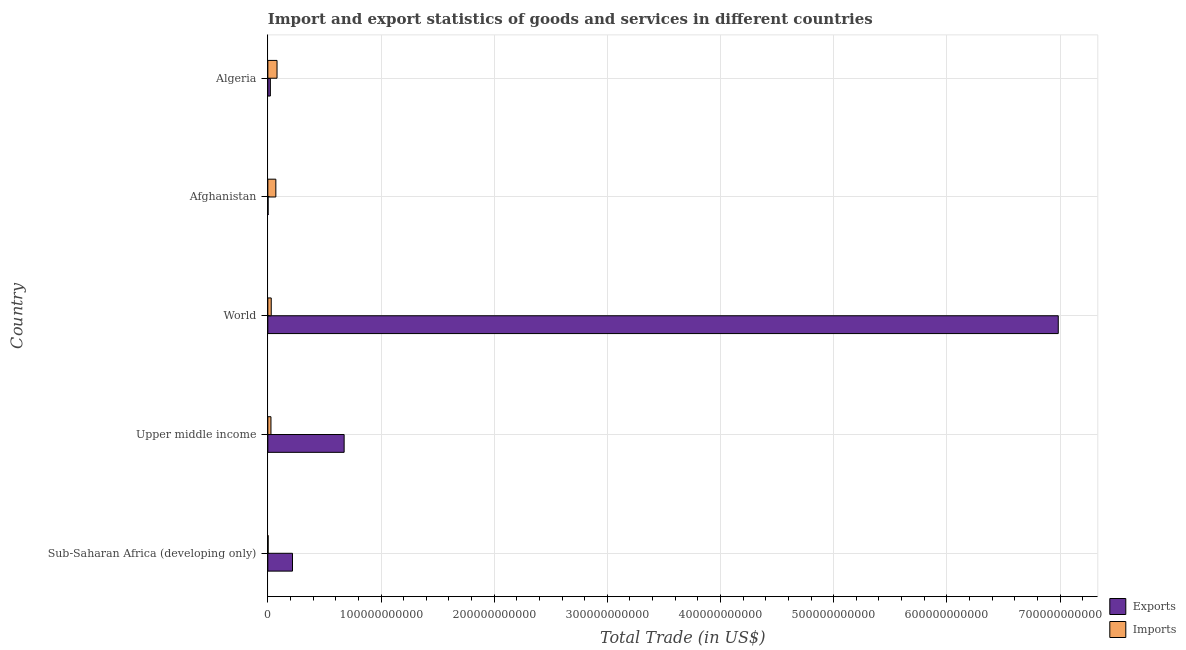Are the number of bars per tick equal to the number of legend labels?
Ensure brevity in your answer.  Yes. Are the number of bars on each tick of the Y-axis equal?
Provide a short and direct response. Yes. How many bars are there on the 2nd tick from the bottom?
Your response must be concise. 2. What is the label of the 3rd group of bars from the top?
Ensure brevity in your answer.  World. What is the imports of goods and services in Algeria?
Your response must be concise. 8.12e+09. Across all countries, what is the maximum imports of goods and services?
Your answer should be very brief. 8.12e+09. Across all countries, what is the minimum imports of goods and services?
Your answer should be very brief. 2.56e+08. In which country was the imports of goods and services minimum?
Ensure brevity in your answer.  Sub-Saharan Africa (developing only). What is the total imports of goods and services in the graph?
Provide a succinct answer. 2.12e+1. What is the difference between the imports of goods and services in Sub-Saharan Africa (developing only) and that in Upper middle income?
Make the answer very short. -2.50e+09. What is the difference between the imports of goods and services in Algeria and the export of goods and services in Afghanistan?
Offer a very short reply. 7.90e+09. What is the average export of goods and services per country?
Make the answer very short. 1.58e+11. What is the difference between the imports of goods and services and export of goods and services in Upper middle income?
Provide a succinct answer. -6.47e+1. In how many countries, is the imports of goods and services greater than 620000000000 US$?
Offer a very short reply. 0. What is the ratio of the export of goods and services in Algeria to that in Sub-Saharan Africa (developing only)?
Your response must be concise. 0.1. Is the difference between the export of goods and services in Afghanistan and Upper middle income greater than the difference between the imports of goods and services in Afghanistan and Upper middle income?
Provide a short and direct response. No. What is the difference between the highest and the second highest imports of goods and services?
Keep it short and to the point. 1.06e+09. What is the difference between the highest and the lowest imports of goods and services?
Offer a very short reply. 7.87e+09. Is the sum of the export of goods and services in Upper middle income and World greater than the maximum imports of goods and services across all countries?
Make the answer very short. Yes. What does the 1st bar from the top in World represents?
Ensure brevity in your answer.  Imports. What does the 1st bar from the bottom in Sub-Saharan Africa (developing only) represents?
Give a very brief answer. Exports. How many bars are there?
Make the answer very short. 10. Are all the bars in the graph horizontal?
Your answer should be compact. Yes. What is the difference between two consecutive major ticks on the X-axis?
Keep it short and to the point. 1.00e+11. Does the graph contain any zero values?
Your answer should be very brief. No. Does the graph contain grids?
Your answer should be compact. Yes. Where does the legend appear in the graph?
Your answer should be very brief. Bottom right. What is the title of the graph?
Your answer should be very brief. Import and export statistics of goods and services in different countries. Does "Official creditors" appear as one of the legend labels in the graph?
Make the answer very short. No. What is the label or title of the X-axis?
Your response must be concise. Total Trade (in US$). What is the label or title of the Y-axis?
Ensure brevity in your answer.  Country. What is the Total Trade (in US$) of Exports in Sub-Saharan Africa (developing only)?
Your response must be concise. 2.18e+1. What is the Total Trade (in US$) in Imports in Sub-Saharan Africa (developing only)?
Keep it short and to the point. 2.56e+08. What is the Total Trade (in US$) in Exports in Upper middle income?
Offer a terse response. 6.74e+1. What is the Total Trade (in US$) of Imports in Upper middle income?
Your response must be concise. 2.75e+09. What is the Total Trade (in US$) of Exports in World?
Ensure brevity in your answer.  6.98e+11. What is the Total Trade (in US$) in Imports in World?
Make the answer very short. 3.00e+09. What is the Total Trade (in US$) of Exports in Afghanistan?
Provide a succinct answer. 2.24e+08. What is the Total Trade (in US$) of Imports in Afghanistan?
Your answer should be compact. 7.06e+09. What is the Total Trade (in US$) of Exports in Algeria?
Offer a terse response. 2.22e+09. What is the Total Trade (in US$) of Imports in Algeria?
Provide a succinct answer. 8.12e+09. Across all countries, what is the maximum Total Trade (in US$) of Exports?
Provide a short and direct response. 6.98e+11. Across all countries, what is the maximum Total Trade (in US$) of Imports?
Your answer should be very brief. 8.12e+09. Across all countries, what is the minimum Total Trade (in US$) in Exports?
Offer a very short reply. 2.24e+08. Across all countries, what is the minimum Total Trade (in US$) in Imports?
Make the answer very short. 2.56e+08. What is the total Total Trade (in US$) in Exports in the graph?
Provide a succinct answer. 7.90e+11. What is the total Total Trade (in US$) of Imports in the graph?
Make the answer very short. 2.12e+1. What is the difference between the Total Trade (in US$) of Exports in Sub-Saharan Africa (developing only) and that in Upper middle income?
Your answer should be very brief. -4.56e+1. What is the difference between the Total Trade (in US$) of Imports in Sub-Saharan Africa (developing only) and that in Upper middle income?
Give a very brief answer. -2.50e+09. What is the difference between the Total Trade (in US$) of Exports in Sub-Saharan Africa (developing only) and that in World?
Give a very brief answer. -6.77e+11. What is the difference between the Total Trade (in US$) of Imports in Sub-Saharan Africa (developing only) and that in World?
Keep it short and to the point. -2.74e+09. What is the difference between the Total Trade (in US$) of Exports in Sub-Saharan Africa (developing only) and that in Afghanistan?
Your answer should be very brief. 2.16e+1. What is the difference between the Total Trade (in US$) in Imports in Sub-Saharan Africa (developing only) and that in Afghanistan?
Keep it short and to the point. -6.81e+09. What is the difference between the Total Trade (in US$) in Exports in Sub-Saharan Africa (developing only) and that in Algeria?
Provide a succinct answer. 1.96e+1. What is the difference between the Total Trade (in US$) of Imports in Sub-Saharan Africa (developing only) and that in Algeria?
Keep it short and to the point. -7.87e+09. What is the difference between the Total Trade (in US$) of Exports in Upper middle income and that in World?
Offer a very short reply. -6.31e+11. What is the difference between the Total Trade (in US$) of Imports in Upper middle income and that in World?
Give a very brief answer. -2.47e+08. What is the difference between the Total Trade (in US$) of Exports in Upper middle income and that in Afghanistan?
Your response must be concise. 6.72e+1. What is the difference between the Total Trade (in US$) in Imports in Upper middle income and that in Afghanistan?
Offer a terse response. -4.31e+09. What is the difference between the Total Trade (in US$) in Exports in Upper middle income and that in Algeria?
Ensure brevity in your answer.  6.52e+1. What is the difference between the Total Trade (in US$) in Imports in Upper middle income and that in Algeria?
Your response must be concise. -5.37e+09. What is the difference between the Total Trade (in US$) of Exports in World and that in Afghanistan?
Keep it short and to the point. 6.98e+11. What is the difference between the Total Trade (in US$) of Imports in World and that in Afghanistan?
Offer a very short reply. -4.06e+09. What is the difference between the Total Trade (in US$) in Exports in World and that in Algeria?
Ensure brevity in your answer.  6.96e+11. What is the difference between the Total Trade (in US$) of Imports in World and that in Algeria?
Your response must be concise. -5.12e+09. What is the difference between the Total Trade (in US$) of Exports in Afghanistan and that in Algeria?
Make the answer very short. -2.00e+09. What is the difference between the Total Trade (in US$) in Imports in Afghanistan and that in Algeria?
Ensure brevity in your answer.  -1.06e+09. What is the difference between the Total Trade (in US$) in Exports in Sub-Saharan Africa (developing only) and the Total Trade (in US$) in Imports in Upper middle income?
Your answer should be very brief. 1.90e+1. What is the difference between the Total Trade (in US$) of Exports in Sub-Saharan Africa (developing only) and the Total Trade (in US$) of Imports in World?
Your response must be concise. 1.88e+1. What is the difference between the Total Trade (in US$) in Exports in Sub-Saharan Africa (developing only) and the Total Trade (in US$) in Imports in Afghanistan?
Your answer should be very brief. 1.47e+1. What is the difference between the Total Trade (in US$) in Exports in Sub-Saharan Africa (developing only) and the Total Trade (in US$) in Imports in Algeria?
Make the answer very short. 1.37e+1. What is the difference between the Total Trade (in US$) of Exports in Upper middle income and the Total Trade (in US$) of Imports in World?
Keep it short and to the point. 6.44e+1. What is the difference between the Total Trade (in US$) in Exports in Upper middle income and the Total Trade (in US$) in Imports in Afghanistan?
Offer a terse response. 6.04e+1. What is the difference between the Total Trade (in US$) of Exports in Upper middle income and the Total Trade (in US$) of Imports in Algeria?
Provide a short and direct response. 5.93e+1. What is the difference between the Total Trade (in US$) in Exports in World and the Total Trade (in US$) in Imports in Afghanistan?
Your answer should be compact. 6.91e+11. What is the difference between the Total Trade (in US$) in Exports in World and the Total Trade (in US$) in Imports in Algeria?
Your answer should be compact. 6.90e+11. What is the difference between the Total Trade (in US$) of Exports in Afghanistan and the Total Trade (in US$) of Imports in Algeria?
Your response must be concise. -7.90e+09. What is the average Total Trade (in US$) of Exports per country?
Offer a terse response. 1.58e+11. What is the average Total Trade (in US$) of Imports per country?
Give a very brief answer. 4.24e+09. What is the difference between the Total Trade (in US$) in Exports and Total Trade (in US$) in Imports in Sub-Saharan Africa (developing only)?
Give a very brief answer. 2.15e+1. What is the difference between the Total Trade (in US$) in Exports and Total Trade (in US$) in Imports in Upper middle income?
Your answer should be compact. 6.47e+1. What is the difference between the Total Trade (in US$) of Exports and Total Trade (in US$) of Imports in World?
Offer a terse response. 6.95e+11. What is the difference between the Total Trade (in US$) in Exports and Total Trade (in US$) in Imports in Afghanistan?
Your answer should be very brief. -6.84e+09. What is the difference between the Total Trade (in US$) in Exports and Total Trade (in US$) in Imports in Algeria?
Keep it short and to the point. -5.90e+09. What is the ratio of the Total Trade (in US$) in Exports in Sub-Saharan Africa (developing only) to that in Upper middle income?
Provide a short and direct response. 0.32. What is the ratio of the Total Trade (in US$) of Imports in Sub-Saharan Africa (developing only) to that in Upper middle income?
Your response must be concise. 0.09. What is the ratio of the Total Trade (in US$) in Exports in Sub-Saharan Africa (developing only) to that in World?
Offer a terse response. 0.03. What is the ratio of the Total Trade (in US$) in Imports in Sub-Saharan Africa (developing only) to that in World?
Make the answer very short. 0.09. What is the ratio of the Total Trade (in US$) of Exports in Sub-Saharan Africa (developing only) to that in Afghanistan?
Keep it short and to the point. 97.05. What is the ratio of the Total Trade (in US$) of Imports in Sub-Saharan Africa (developing only) to that in Afghanistan?
Give a very brief answer. 0.04. What is the ratio of the Total Trade (in US$) in Exports in Sub-Saharan Africa (developing only) to that in Algeria?
Give a very brief answer. 9.8. What is the ratio of the Total Trade (in US$) in Imports in Sub-Saharan Africa (developing only) to that in Algeria?
Your response must be concise. 0.03. What is the ratio of the Total Trade (in US$) of Exports in Upper middle income to that in World?
Your response must be concise. 0.1. What is the ratio of the Total Trade (in US$) of Imports in Upper middle income to that in World?
Provide a succinct answer. 0.92. What is the ratio of the Total Trade (in US$) of Exports in Upper middle income to that in Afghanistan?
Your answer should be compact. 300.39. What is the ratio of the Total Trade (in US$) in Imports in Upper middle income to that in Afghanistan?
Ensure brevity in your answer.  0.39. What is the ratio of the Total Trade (in US$) of Exports in Upper middle income to that in Algeria?
Provide a succinct answer. 30.33. What is the ratio of the Total Trade (in US$) in Imports in Upper middle income to that in Algeria?
Provide a short and direct response. 0.34. What is the ratio of the Total Trade (in US$) in Exports in World to that in Afghanistan?
Your answer should be compact. 3111.96. What is the ratio of the Total Trade (in US$) in Imports in World to that in Afghanistan?
Provide a short and direct response. 0.42. What is the ratio of the Total Trade (in US$) of Exports in World to that in Algeria?
Keep it short and to the point. 314.24. What is the ratio of the Total Trade (in US$) of Imports in World to that in Algeria?
Offer a very short reply. 0.37. What is the ratio of the Total Trade (in US$) in Exports in Afghanistan to that in Algeria?
Make the answer very short. 0.1. What is the ratio of the Total Trade (in US$) of Imports in Afghanistan to that in Algeria?
Your answer should be very brief. 0.87. What is the difference between the highest and the second highest Total Trade (in US$) in Exports?
Give a very brief answer. 6.31e+11. What is the difference between the highest and the second highest Total Trade (in US$) in Imports?
Give a very brief answer. 1.06e+09. What is the difference between the highest and the lowest Total Trade (in US$) in Exports?
Offer a very short reply. 6.98e+11. What is the difference between the highest and the lowest Total Trade (in US$) of Imports?
Ensure brevity in your answer.  7.87e+09. 